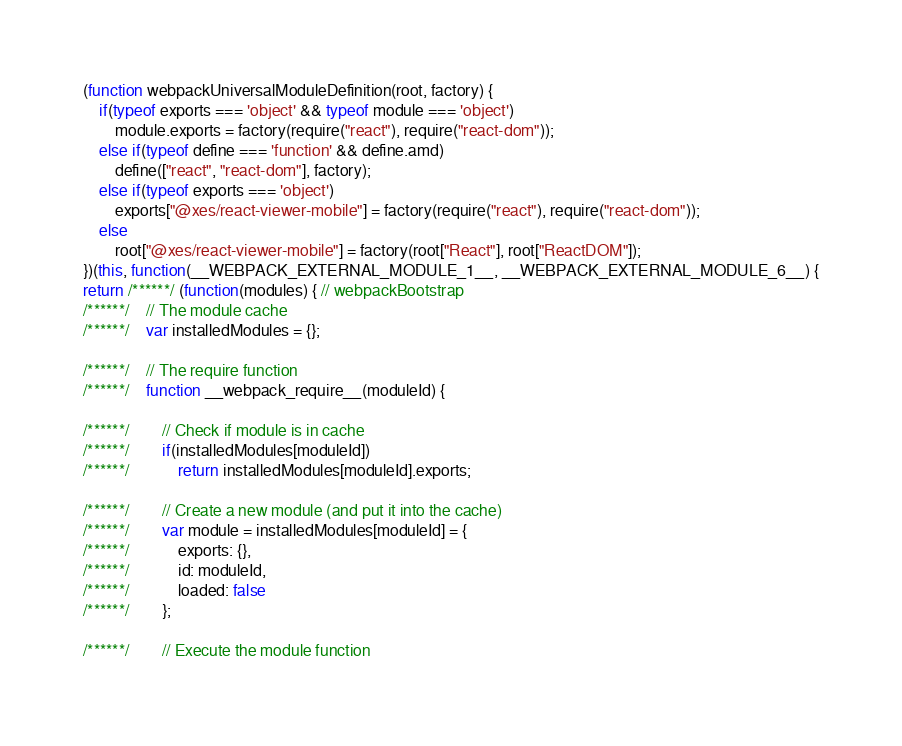Convert code to text. <code><loc_0><loc_0><loc_500><loc_500><_JavaScript_>(function webpackUniversalModuleDefinition(root, factory) {
	if(typeof exports === 'object' && typeof module === 'object')
		module.exports = factory(require("react"), require("react-dom"));
	else if(typeof define === 'function' && define.amd)
		define(["react", "react-dom"], factory);
	else if(typeof exports === 'object')
		exports["@xes/react-viewer-mobile"] = factory(require("react"), require("react-dom"));
	else
		root["@xes/react-viewer-mobile"] = factory(root["React"], root["ReactDOM"]);
})(this, function(__WEBPACK_EXTERNAL_MODULE_1__, __WEBPACK_EXTERNAL_MODULE_6__) {
return /******/ (function(modules) { // webpackBootstrap
/******/ 	// The module cache
/******/ 	var installedModules = {};

/******/ 	// The require function
/******/ 	function __webpack_require__(moduleId) {

/******/ 		// Check if module is in cache
/******/ 		if(installedModules[moduleId])
/******/ 			return installedModules[moduleId].exports;

/******/ 		// Create a new module (and put it into the cache)
/******/ 		var module = installedModules[moduleId] = {
/******/ 			exports: {},
/******/ 			id: moduleId,
/******/ 			loaded: false
/******/ 		};

/******/ 		// Execute the module function</code> 